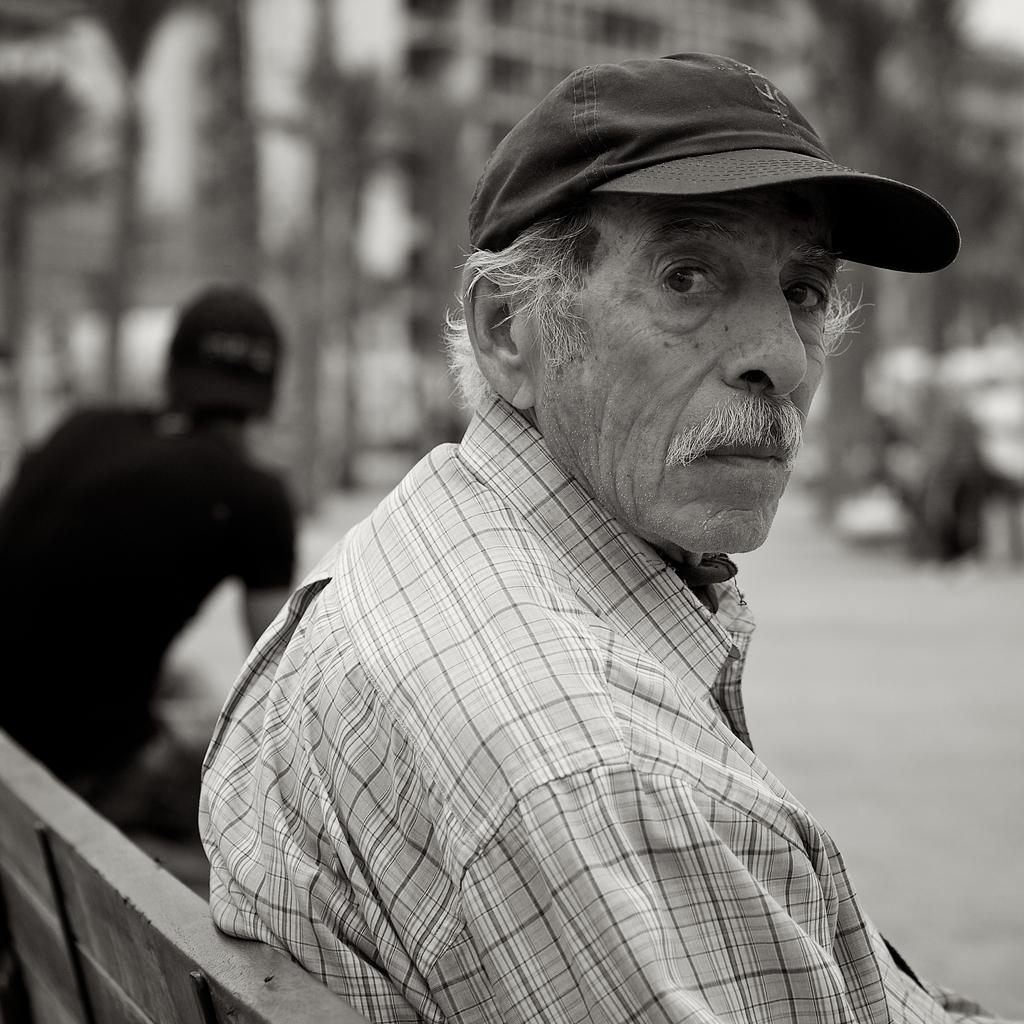How many people are in the image? There are two people sitting on a bench in the image. What can be seen in the background of the image? The background of the image includes buildings. How is the background of the image depicted? The background is blurred. Can you see a crown on the head of either person in the image? There is no crown present on the heads of the people in the image. Is the image taken near a coast? The image does not depict a coast; it features a bench and buildings in the background. 